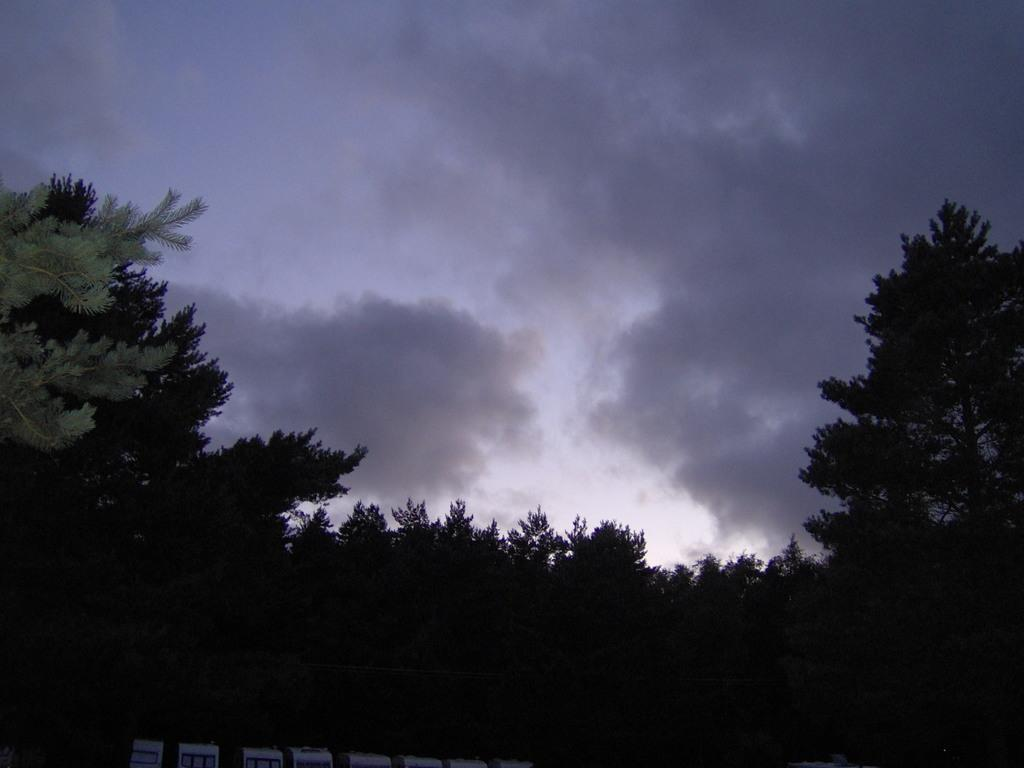What can be seen at the top of the image? The sky is visible towards the top of the image. What is present in the sky? There are clouds in the sky. What type of vegetation is in the image? There are trees in the image. What is located towards the bottom of the image? There is a group of objects towards the bottom of the image. What color is the orange that is being used for sleep in the image? There is no orange or reference to sleep in the image. 